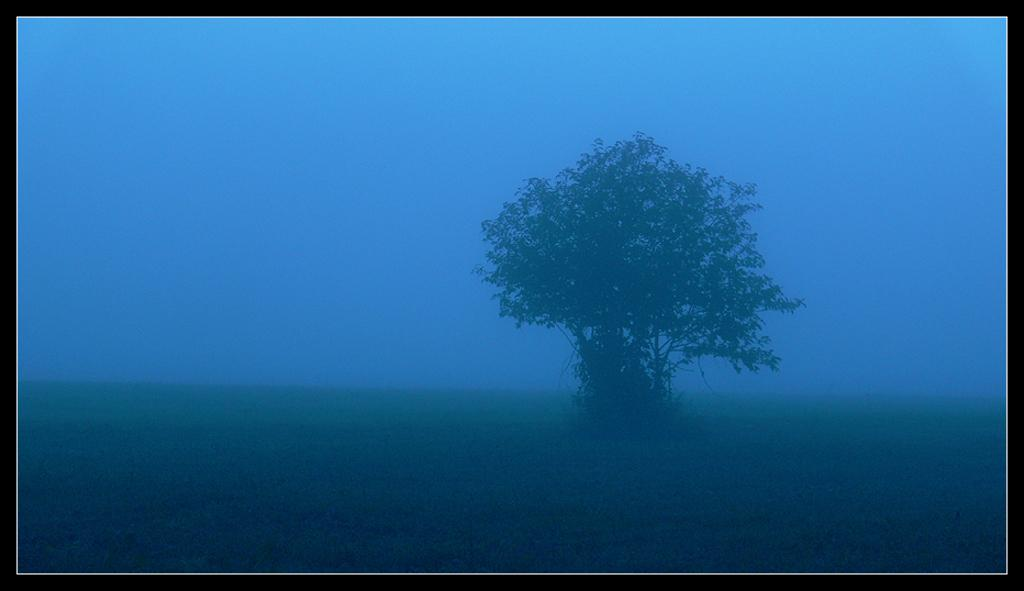What type of image is being described? The image is a photo. What can be seen on the ground in the photo? There is a tree on the ground in the image. What is visible at the top of the photo? The sky is visible at the top of the image. What is the texture of the chin in the image? There is no chin present in the image, as it features a tree and the sky. 